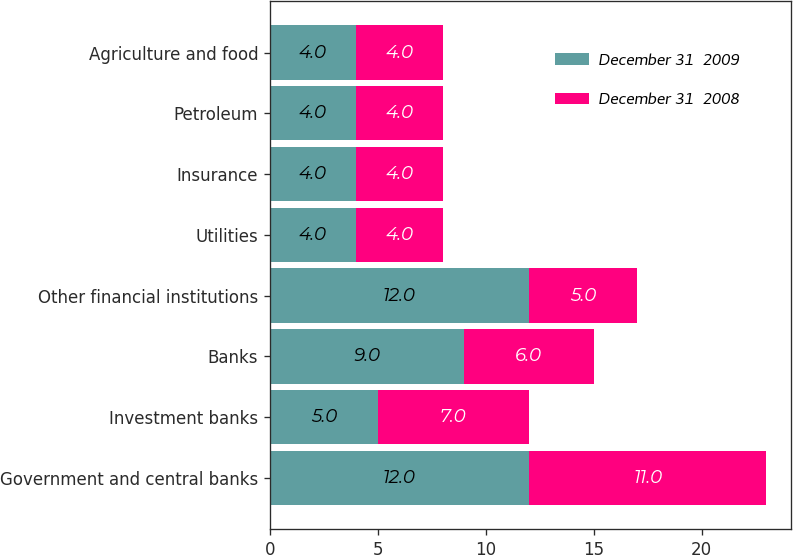Convert chart. <chart><loc_0><loc_0><loc_500><loc_500><stacked_bar_chart><ecel><fcel>Government and central banks<fcel>Investment banks<fcel>Banks<fcel>Other financial institutions<fcel>Utilities<fcel>Insurance<fcel>Petroleum<fcel>Agriculture and food<nl><fcel>December 31  2009<fcel>12<fcel>5<fcel>9<fcel>12<fcel>4<fcel>4<fcel>4<fcel>4<nl><fcel>December 31  2008<fcel>11<fcel>7<fcel>6<fcel>5<fcel>4<fcel>4<fcel>4<fcel>4<nl></chart> 